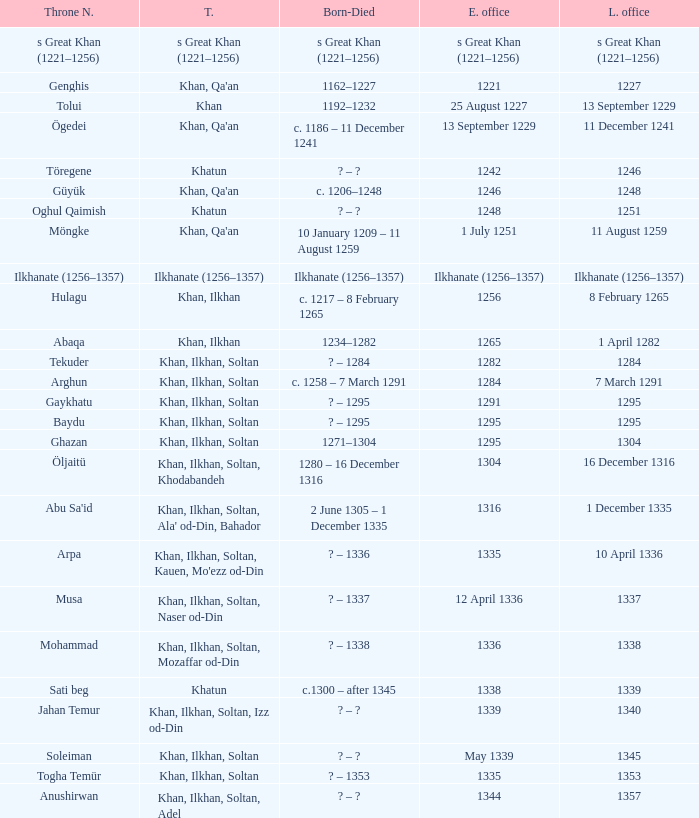What is the born-died that has office of 13 September 1229 as the entered? C. 1186 – 11 december 1241. 